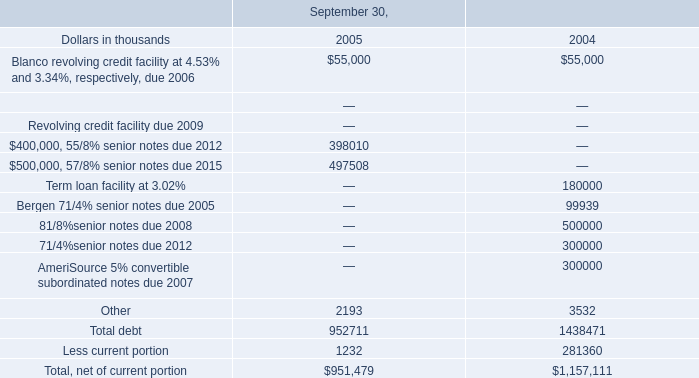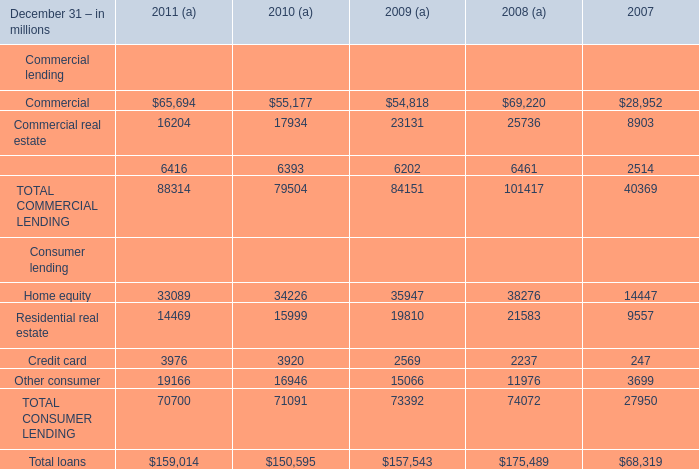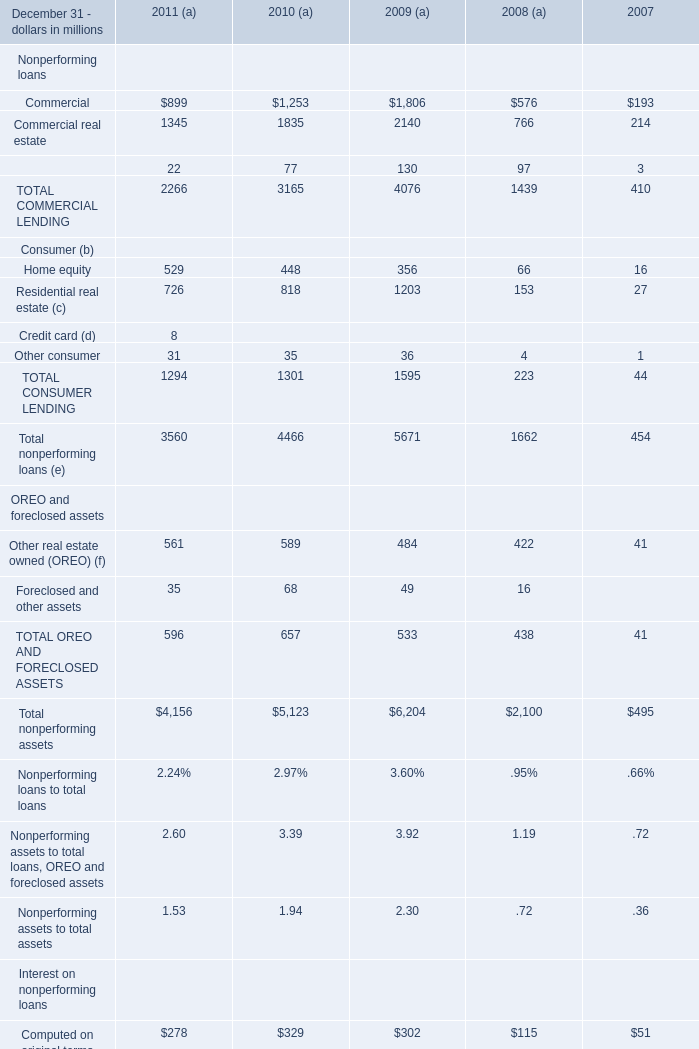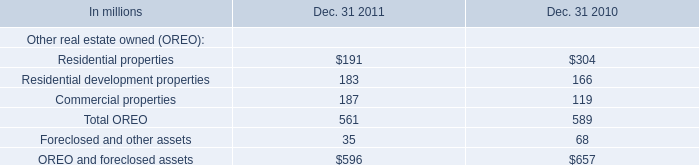In the year with largest amount of Home equity, what's the increasing rate of Residential real estate? 
Computations: ((21583 - 9557) / 9557)
Answer: 1.25834. 